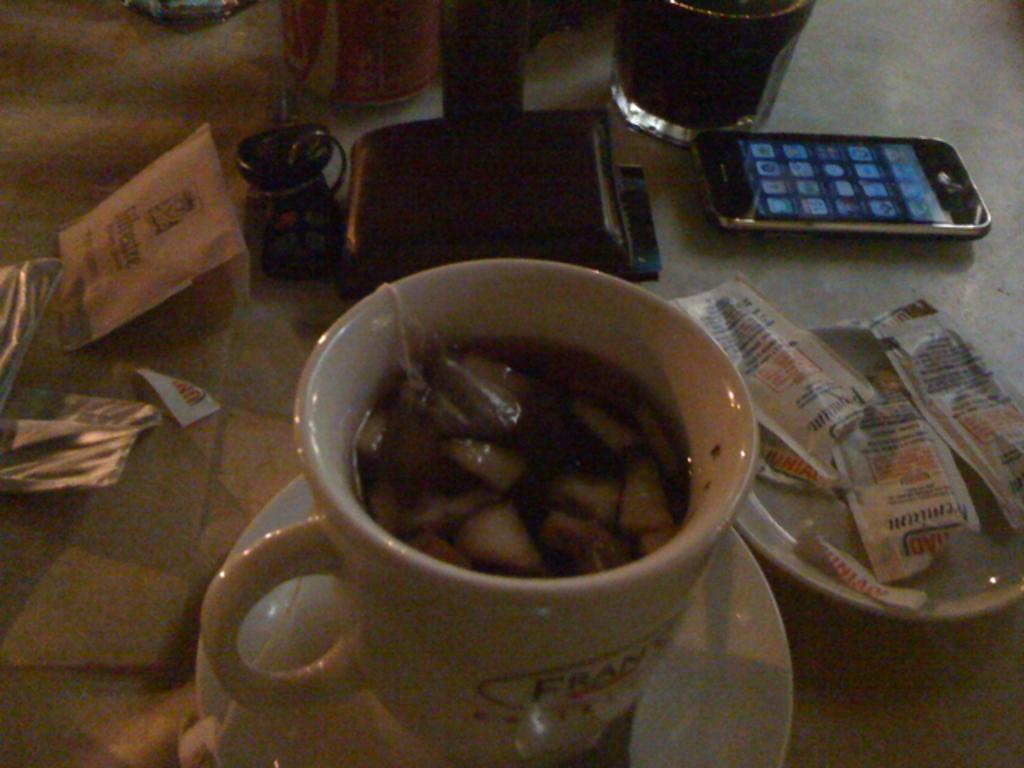What type of furniture is present in the image? There is a table in the image. What items are placed on the table? There are plates, a bowl, a glass, and a mobile phone on the table. Can you describe the purpose of the bowl? The purpose of the bowl is not explicitly stated, but it could be used for holding food or other items. What type of device is present on the table? There is a mobile phone on the table. What type of writing can be seen on the mobile phone in the image? There is no writing visible on the mobile phone in the image. 